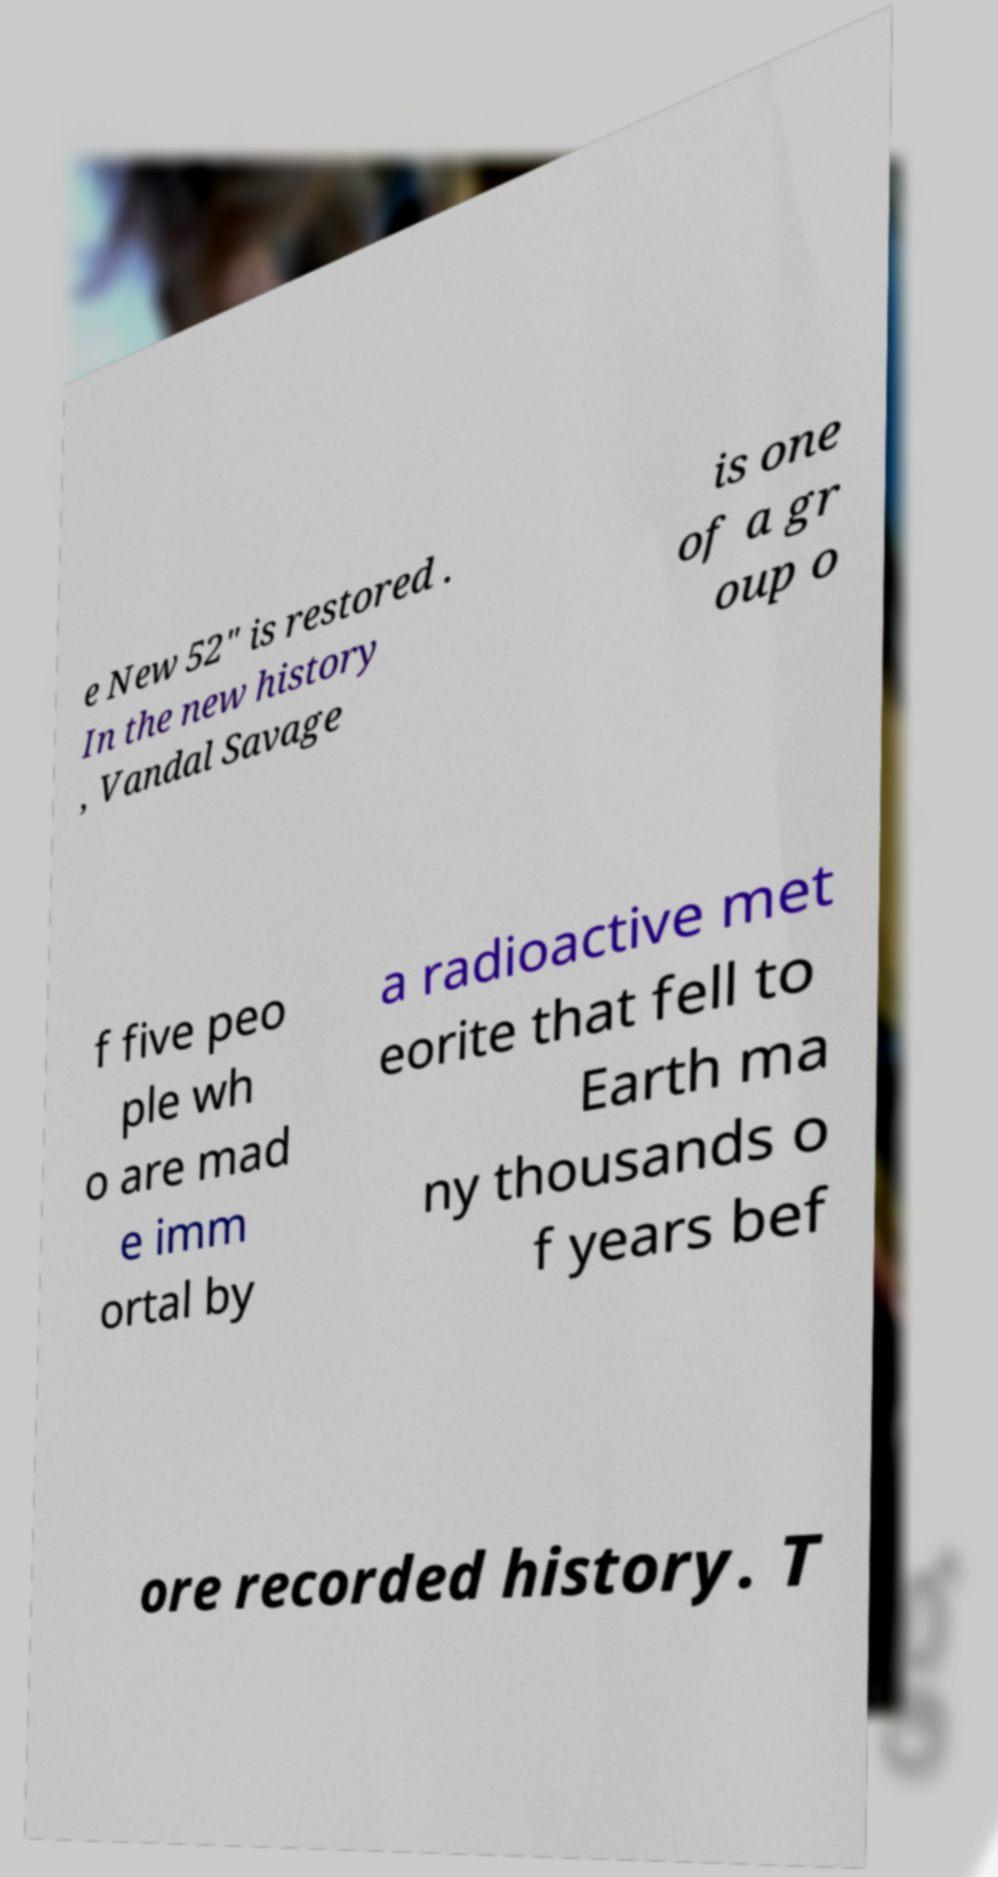Could you assist in decoding the text presented in this image and type it out clearly? e New 52" is restored . In the new history , Vandal Savage is one of a gr oup o f five peo ple wh o are mad e imm ortal by a radioactive met eorite that fell to Earth ma ny thousands o f years bef ore recorded history. T 